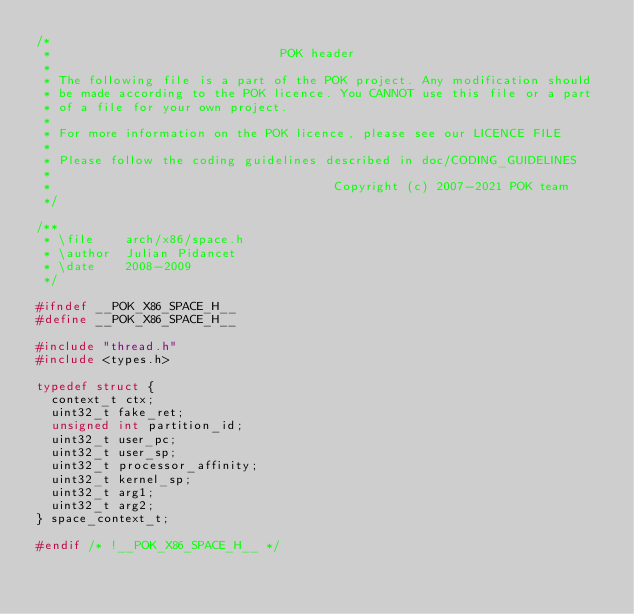Convert code to text. <code><loc_0><loc_0><loc_500><loc_500><_C_>/*
 *                               POK header
 *
 * The following file is a part of the POK project. Any modification should
 * be made according to the POK licence. You CANNOT use this file or a part
 * of a file for your own project.
 *
 * For more information on the POK licence, please see our LICENCE FILE
 *
 * Please follow the coding guidelines described in doc/CODING_GUIDELINES
 *
 *                                      Copyright (c) 2007-2021 POK team
 */

/**
 * \file    arch/x86/space.h
 * \author  Julian Pidancet
 * \date    2008-2009
 */

#ifndef __POK_X86_SPACE_H__
#define __POK_X86_SPACE_H__

#include "thread.h"
#include <types.h>

typedef struct {
  context_t ctx;
  uint32_t fake_ret;
  unsigned int partition_id;
  uint32_t user_pc;
  uint32_t user_sp;
  uint32_t processor_affinity;
  uint32_t kernel_sp;
  uint32_t arg1;
  uint32_t arg2;
} space_context_t;

#endif /* !__POK_X86_SPACE_H__ */
</code> 